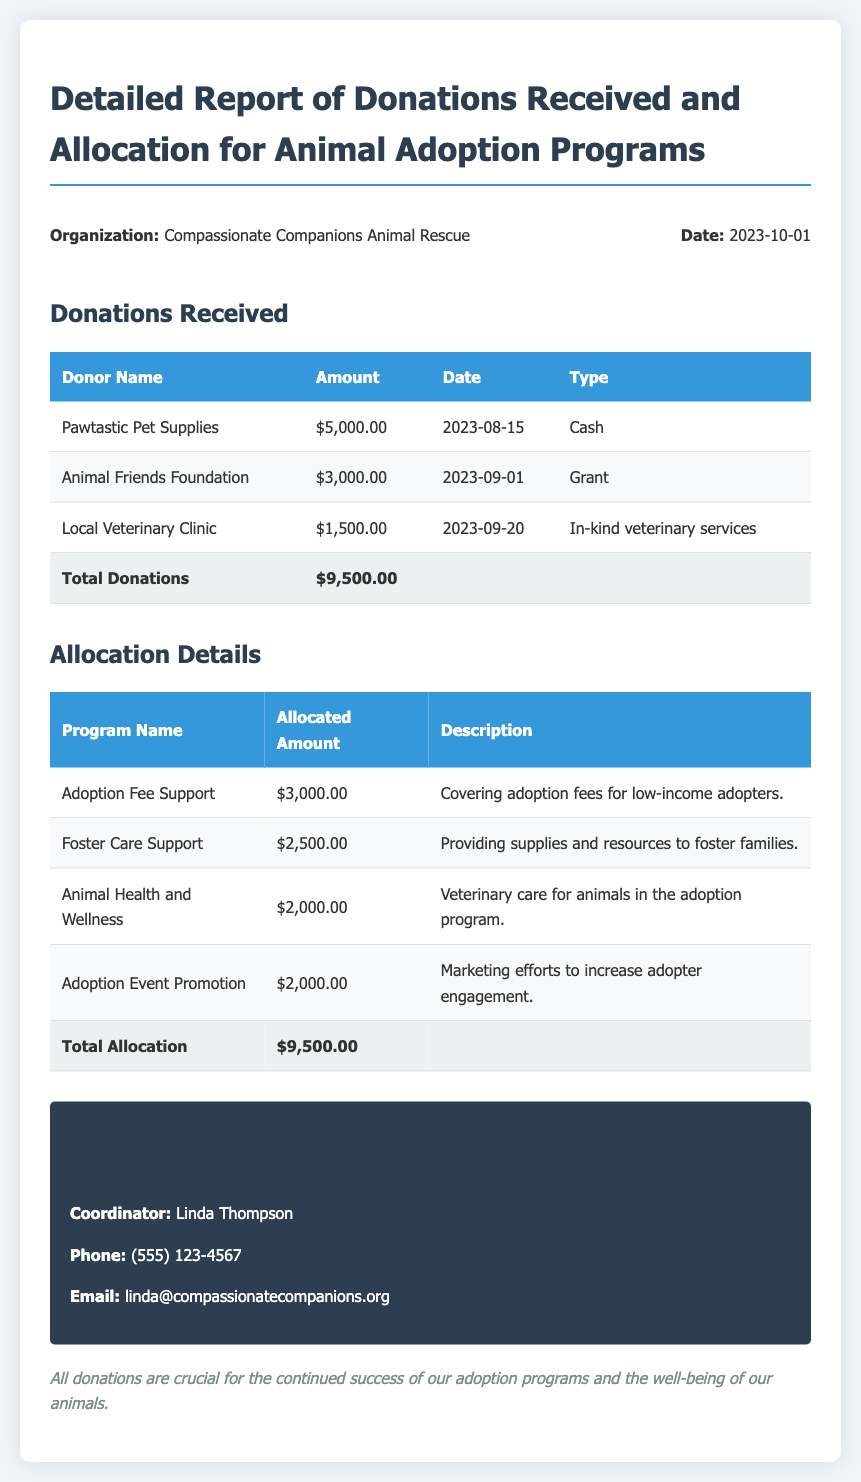What is the total amount of donations received? The total amount of donations received is summarized in the report, which lists all donations made and their total sum.
Answer: $9,500.00 Who is the coordinator listed in the report? The report provides contact information for the adoption coordinator, which includes their name.
Answer: Linda Thompson What is the allocated amount for Animal Health and Wellness? This can be found in the allocation details section under the respective program name.
Answer: $2,000.00 What type of donation was received from the Local Veterinary Clinic? The type of donation is specified in the donations received table, detailing the nature of the contribution.
Answer: In-kind veterinary services What is the description of the Adoption Fee Support program? The description explains the purpose of the allocation, found in the allocation details section.
Answer: Covering adoption fees for low-income adopters How much funding was allocated for Foster Care Support? The allocation details section lists the amounts assigned to each program, including Foster Care Support.
Answer: $2,500.00 What date is listed on the report? The report includes a date for reference, typically found in the report information section.
Answer: 2023-10-01 Which donor contributed the highest amount? The donations received table allows us to identify which donor made the largest contribution.
Answer: Pawtastic Pet Supplies What program received the same allocated amount as Adoption Event Promotion? By comparing the allocated amounts, we can identify other programs with the same funding.
Answer: Adoption Event Promotion (also $2,000.00) 